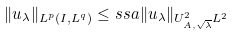Convert formula to latex. <formula><loc_0><loc_0><loc_500><loc_500>\| u _ { \lambda } \| _ { L ^ { p } ( I , L ^ { q } ) } \leq s s a \| u _ { \lambda } \| _ { U ^ { 2 } _ { A , \sqrt { \lambda } } L ^ { 2 } }</formula> 